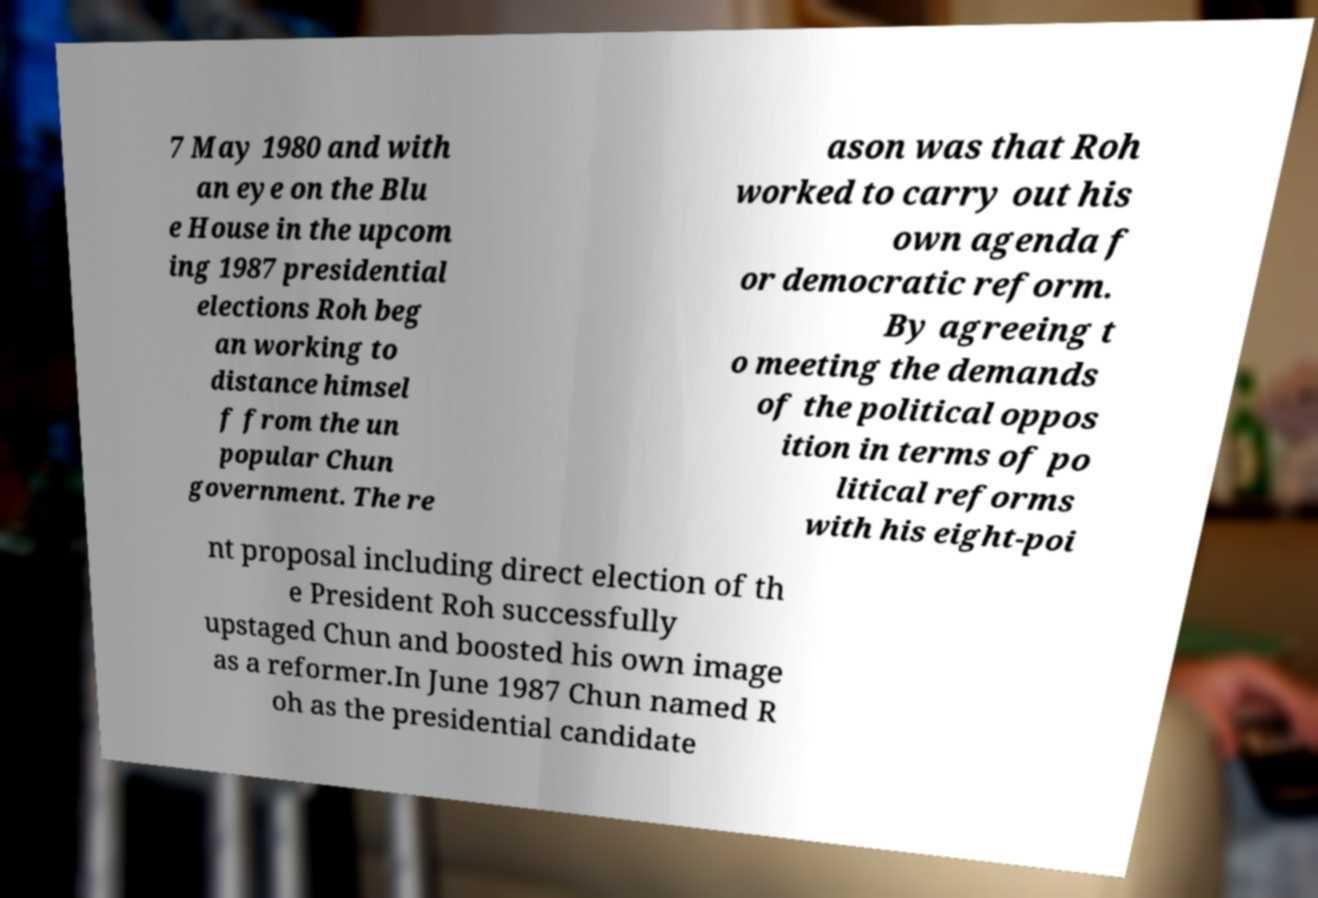Could you assist in decoding the text presented in this image and type it out clearly? 7 May 1980 and with an eye on the Blu e House in the upcom ing 1987 presidential elections Roh beg an working to distance himsel f from the un popular Chun government. The re ason was that Roh worked to carry out his own agenda f or democratic reform. By agreeing t o meeting the demands of the political oppos ition in terms of po litical reforms with his eight-poi nt proposal including direct election of th e President Roh successfully upstaged Chun and boosted his own image as a reformer.In June 1987 Chun named R oh as the presidential candidate 